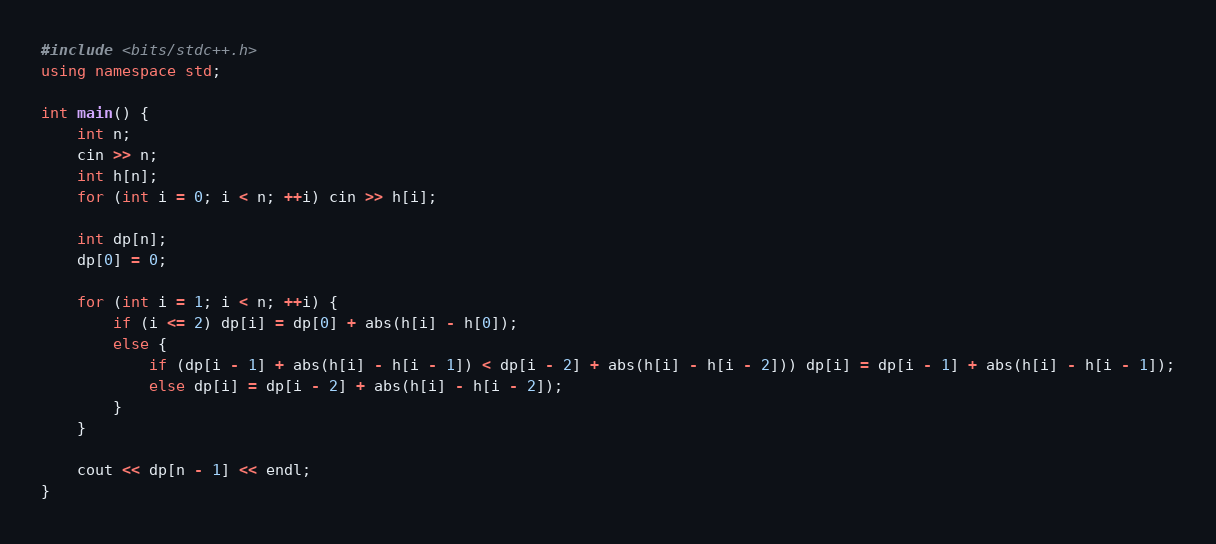Convert code to text. <code><loc_0><loc_0><loc_500><loc_500><_C++_>#include <bits/stdc++.h>
using namespace std;

int main() {
    int n;
    cin >> n;
    int h[n];
    for (int i = 0; i < n; ++i) cin >> h[i];

    int dp[n];
    dp[0] = 0;

    for (int i = 1; i < n; ++i) {
        if (i <= 2) dp[i] = dp[0] + abs(h[i] - h[0]);
        else {
            if (dp[i - 1] + abs(h[i] - h[i - 1]) < dp[i - 2] + abs(h[i] - h[i - 2])) dp[i] = dp[i - 1] + abs(h[i] - h[i - 1]);
            else dp[i] = dp[i - 2] + abs(h[i] - h[i - 2]);
        }
    }

    cout << dp[n - 1] << endl;
}
</code> 